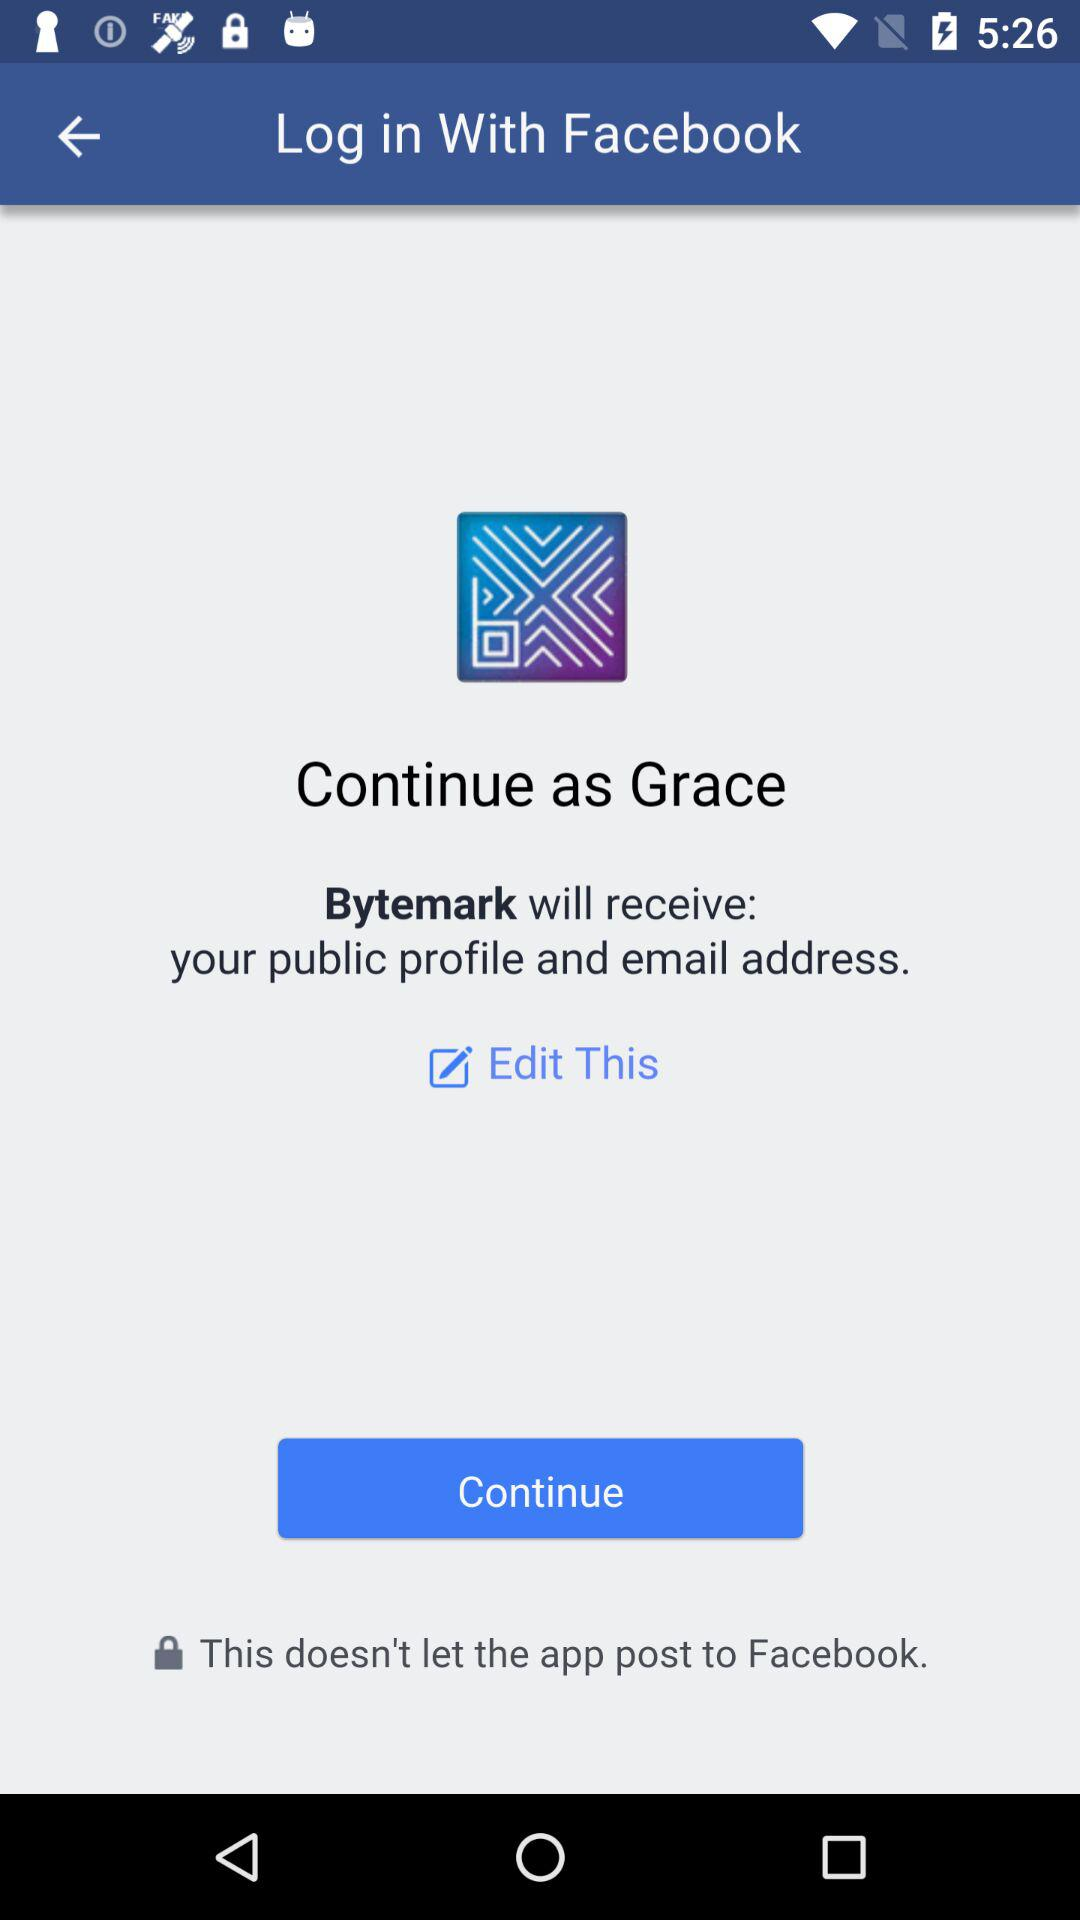What is the login name? The login name is Grace. 